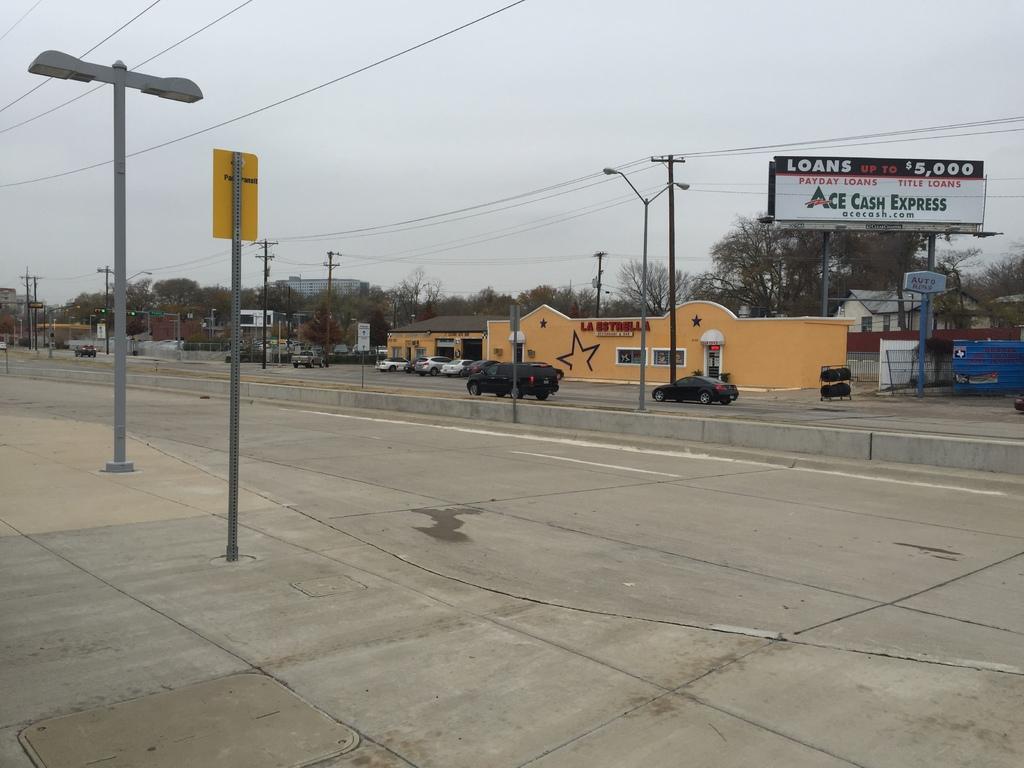Could you give a brief overview of what you see in this image? In this image there are cars on the road. There are light poles, electrical poles with cables. There are boards and a few other objects. In the background of the image there are trees, buildings. At the top of the image there is sky. 